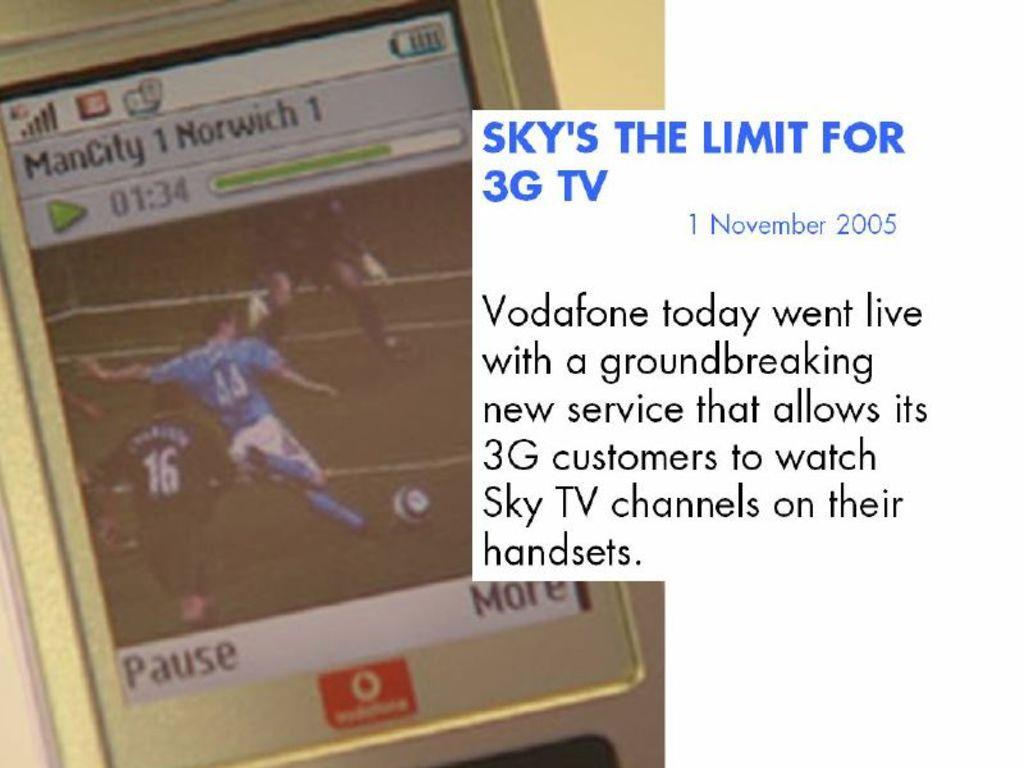Who went live?
Your answer should be very brief. Vodafone. What do they allow customers to do?
Offer a very short reply. Watch sky tv. 